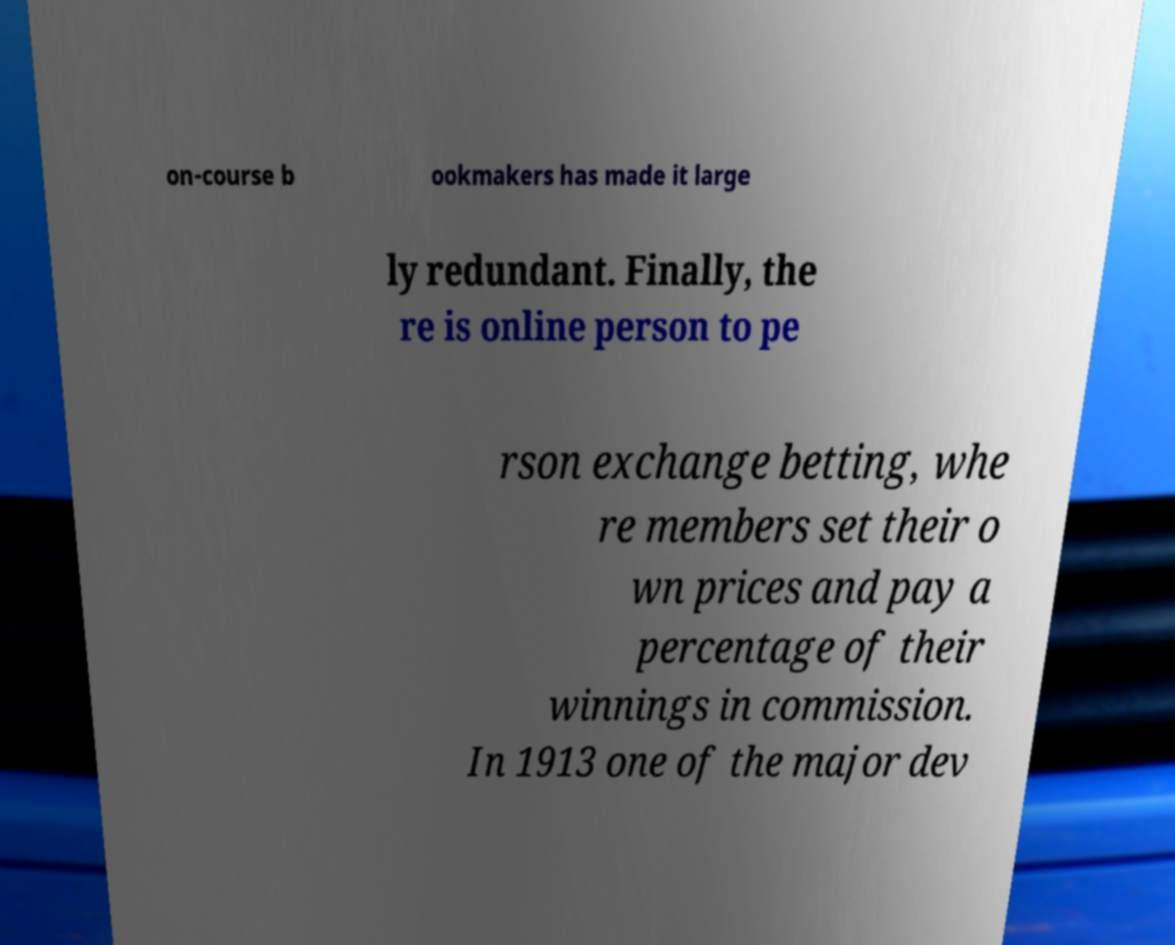Please read and relay the text visible in this image. What does it say? on-course b ookmakers has made it large ly redundant. Finally, the re is online person to pe rson exchange betting, whe re members set their o wn prices and pay a percentage of their winnings in commission. In 1913 one of the major dev 